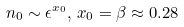Convert formula to latex. <formula><loc_0><loc_0><loc_500><loc_500>n _ { 0 } \sim \epsilon ^ { x _ { 0 } } , \, x _ { 0 } = \beta \approx 0 . 2 8</formula> 